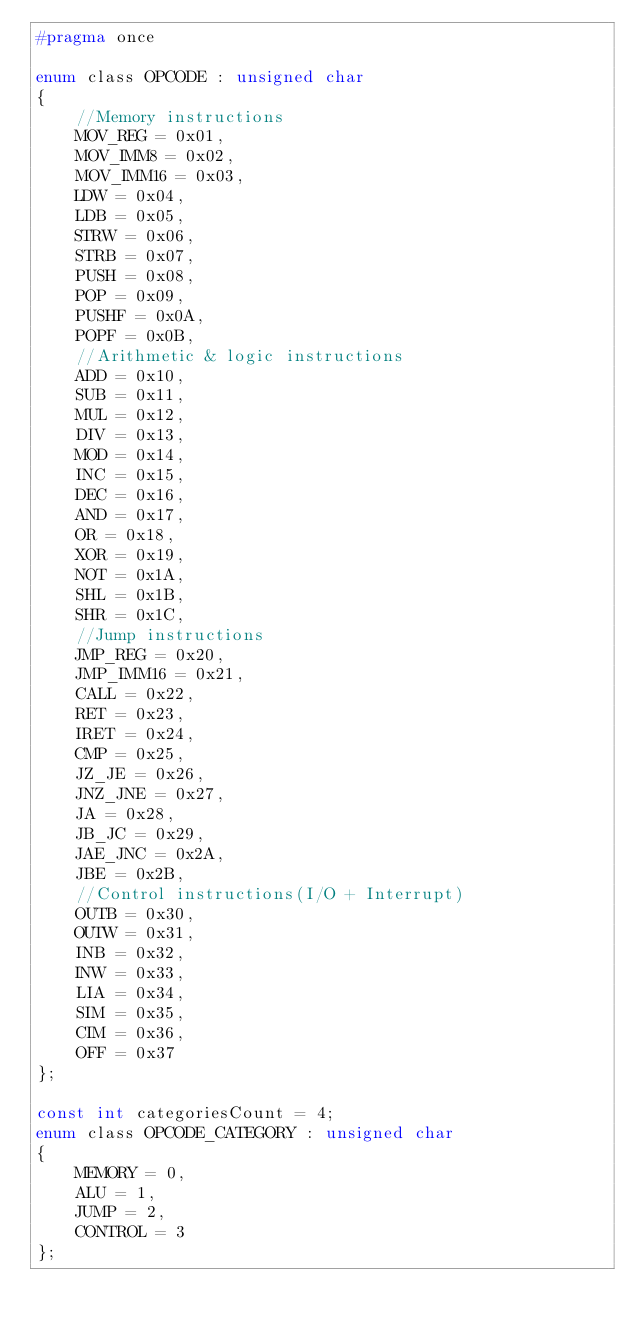Convert code to text. <code><loc_0><loc_0><loc_500><loc_500><_C_>#pragma once

enum class OPCODE : unsigned char
{
    //Memory instructions
    MOV_REG = 0x01,
    MOV_IMM8 = 0x02,
    MOV_IMM16 = 0x03,
    LDW = 0x04,
    LDB = 0x05,
    STRW = 0x06,
    STRB = 0x07,
    PUSH = 0x08,
    POP = 0x09,
    PUSHF = 0x0A,
    POPF = 0x0B,
    //Arithmetic & logic instructions
    ADD = 0x10,
    SUB = 0x11,
    MUL = 0x12,
    DIV = 0x13,
    MOD = 0x14,
    INC = 0x15,
    DEC = 0x16,
    AND = 0x17,
    OR = 0x18,
    XOR = 0x19,
    NOT = 0x1A,
    SHL = 0x1B,
    SHR = 0x1C,
    //Jump instructions
    JMP_REG = 0x20,
    JMP_IMM16 = 0x21,
    CALL = 0x22,
    RET = 0x23,
    IRET = 0x24,
    CMP = 0x25,
    JZ_JE = 0x26,
    JNZ_JNE = 0x27,
    JA = 0x28,
    JB_JC = 0x29,
    JAE_JNC = 0x2A,
    JBE = 0x2B,
    //Control instructions(I/O + Interrupt)
    OUTB = 0x30,
    OUTW = 0x31,
    INB = 0x32,
    INW = 0x33,
    LIA = 0x34,
    SIM = 0x35,
    CIM = 0x36,
    OFF = 0x37
};

const int categoriesCount = 4;
enum class OPCODE_CATEGORY : unsigned char
{
    MEMORY = 0,
    ALU = 1,
    JUMP = 2,
    CONTROL = 3
};
</code> 